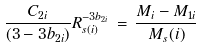Convert formula to latex. <formula><loc_0><loc_0><loc_500><loc_500>\frac { C _ { 2 i } } { ( 3 - 3 b _ { 2 i } ) } R ^ { - 3 b _ { 2 i } } _ { s ( i ) } \, = \, \frac { M _ { i } - M _ { 1 i } } { M _ { s } ( i ) }</formula> 